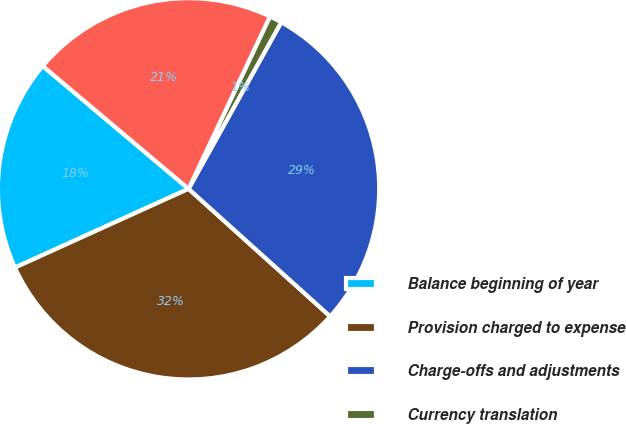<chart> <loc_0><loc_0><loc_500><loc_500><pie_chart><fcel>Balance beginning of year<fcel>Provision charged to expense<fcel>Charge-offs and adjustments<fcel>Currency translation<fcel>Balance end of year<nl><fcel>17.92%<fcel>31.55%<fcel>28.59%<fcel>1.06%<fcel>20.88%<nl></chart> 